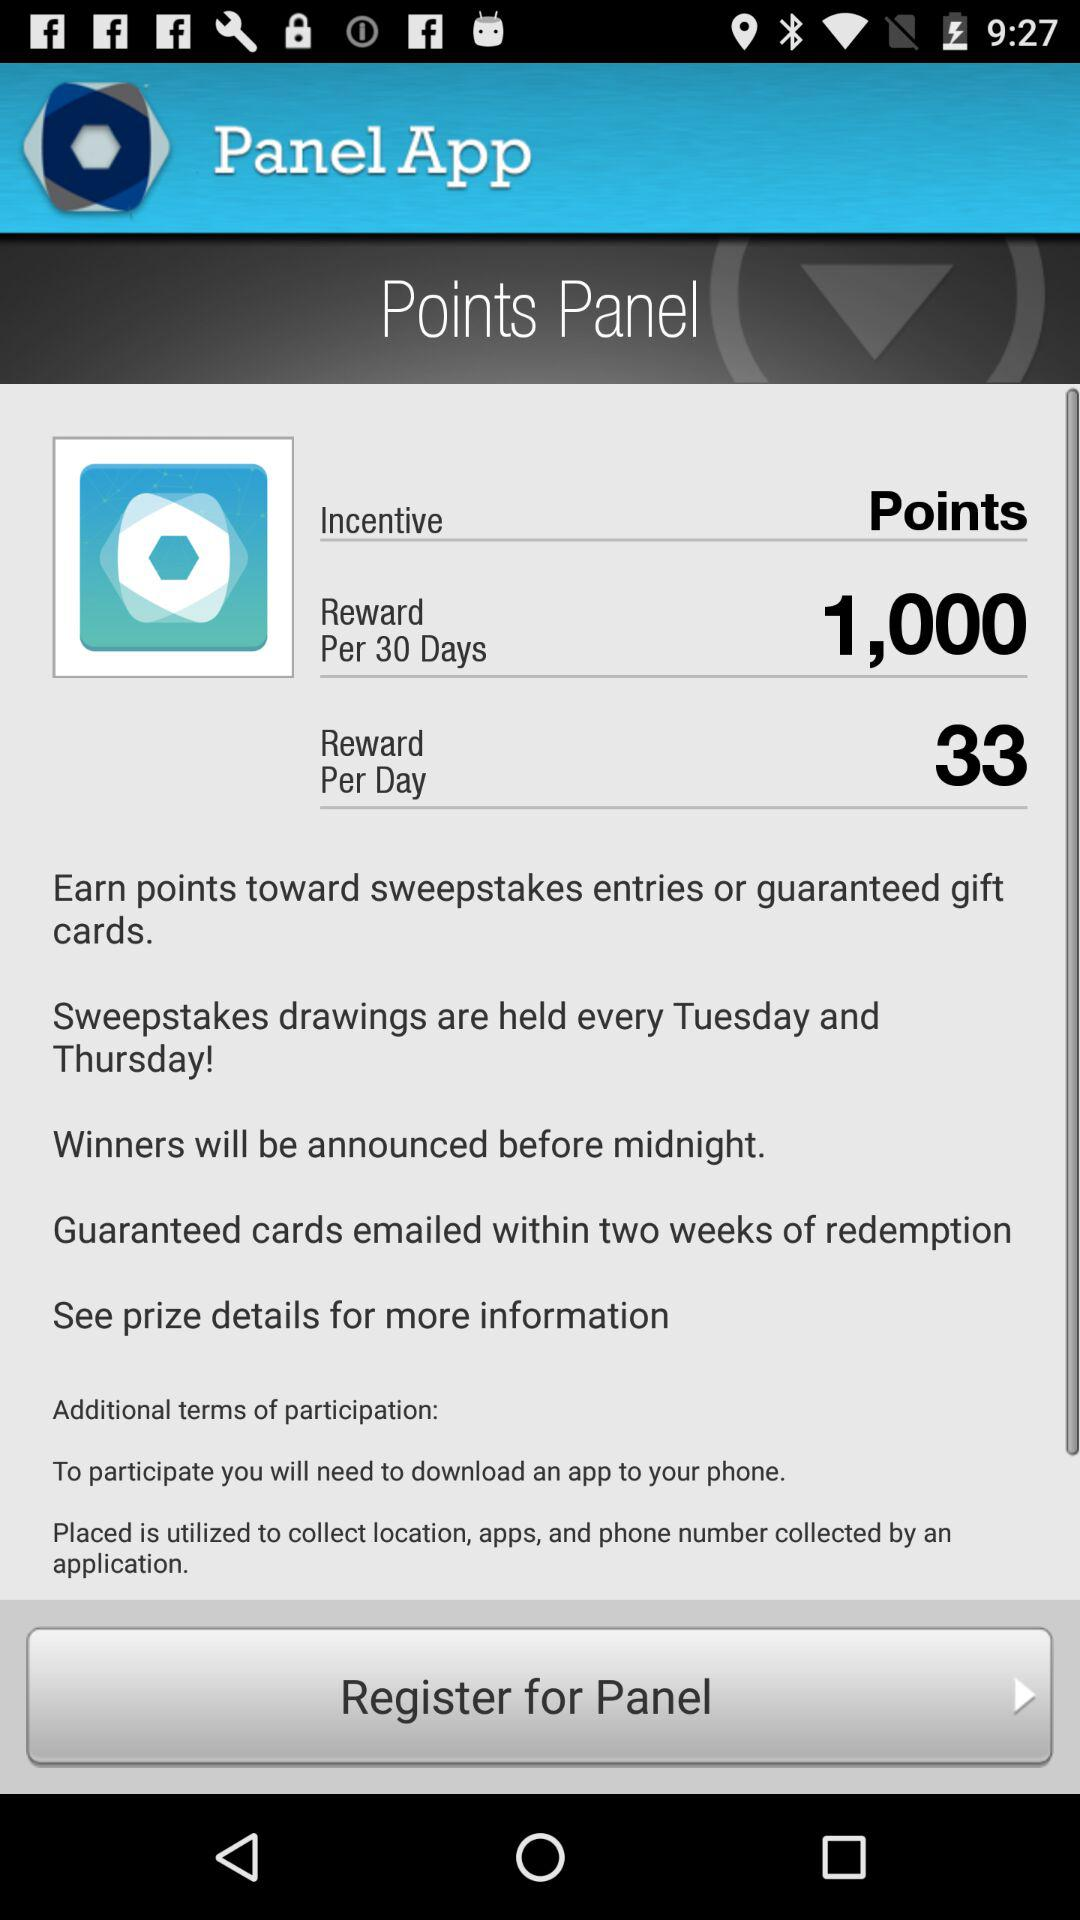How many total rewards per 30 days? The total reward per 30 days is 1,000. 